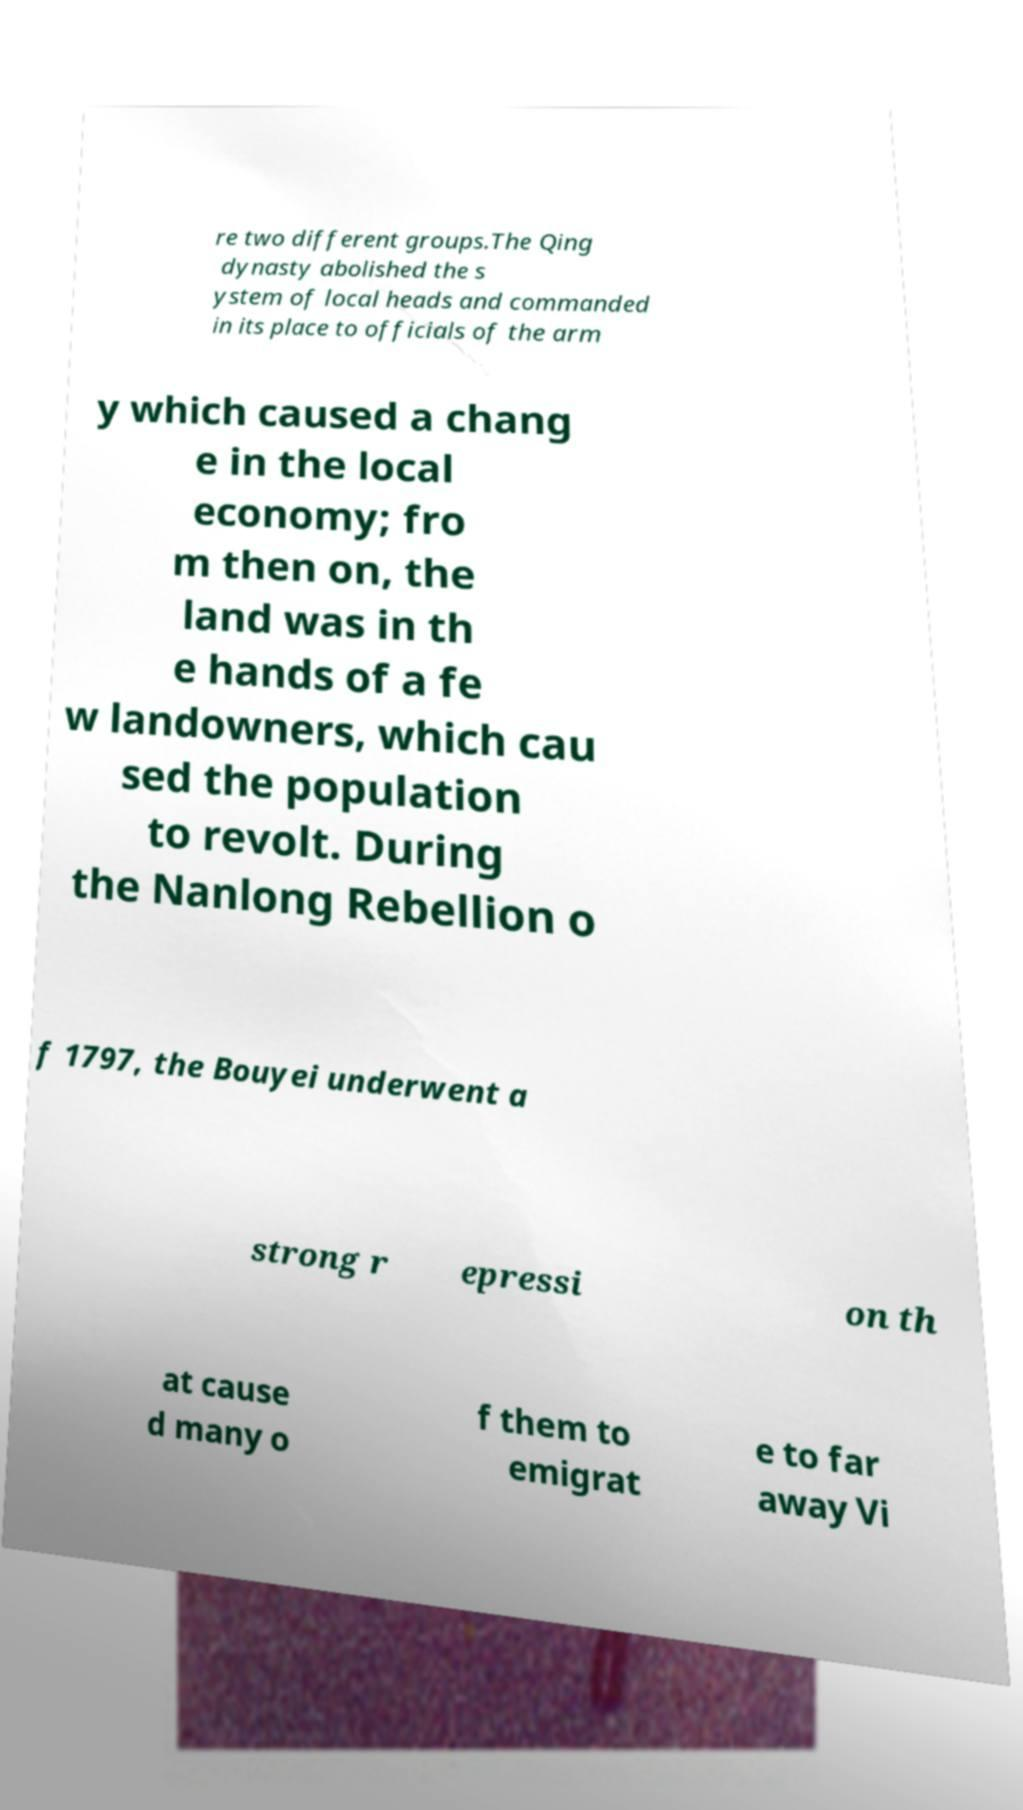For documentation purposes, I need the text within this image transcribed. Could you provide that? re two different groups.The Qing dynasty abolished the s ystem of local heads and commanded in its place to officials of the arm y which caused a chang e in the local economy; fro m then on, the land was in th e hands of a fe w landowners, which cau sed the population to revolt. During the Nanlong Rebellion o f 1797, the Bouyei underwent a strong r epressi on th at cause d many o f them to emigrat e to far away Vi 